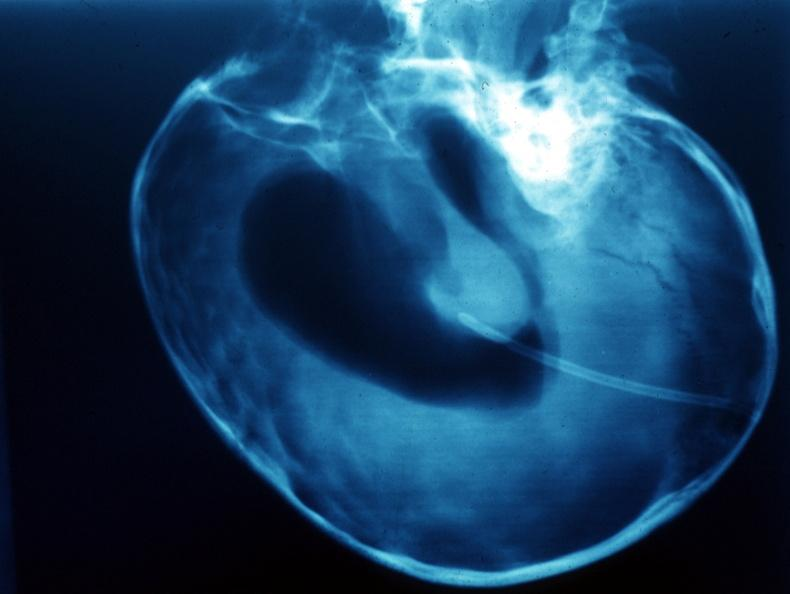s brain present?
Answer the question using a single word or phrase. Yes 